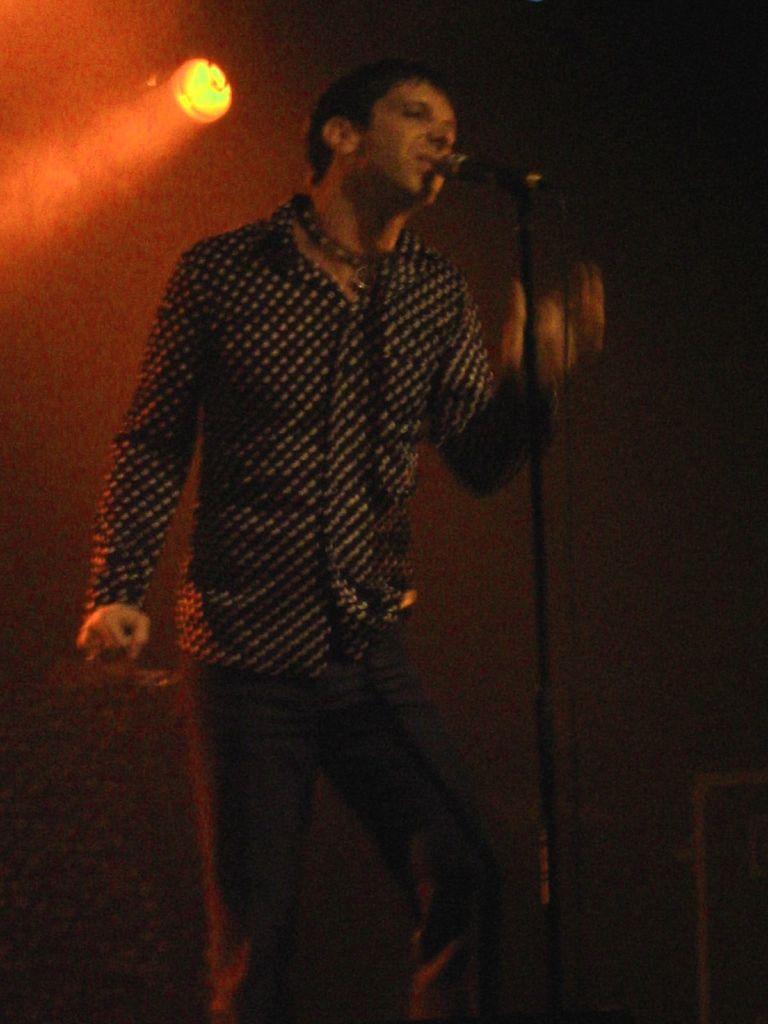Could you give a brief overview of what you see in this image? In the picture we can see a man standing and singing a song in the microphone in front of him and he is with black shirt and black dots on it and behind him we can see a light. 